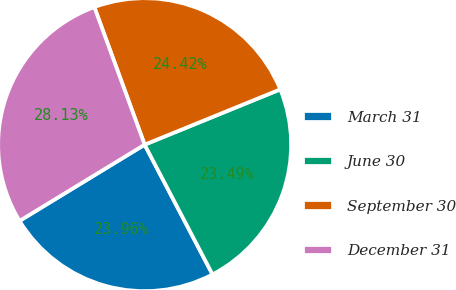<chart> <loc_0><loc_0><loc_500><loc_500><pie_chart><fcel>March 31<fcel>June 30<fcel>September 30<fcel>December 31<nl><fcel>23.96%<fcel>23.49%<fcel>24.42%<fcel>28.13%<nl></chart> 